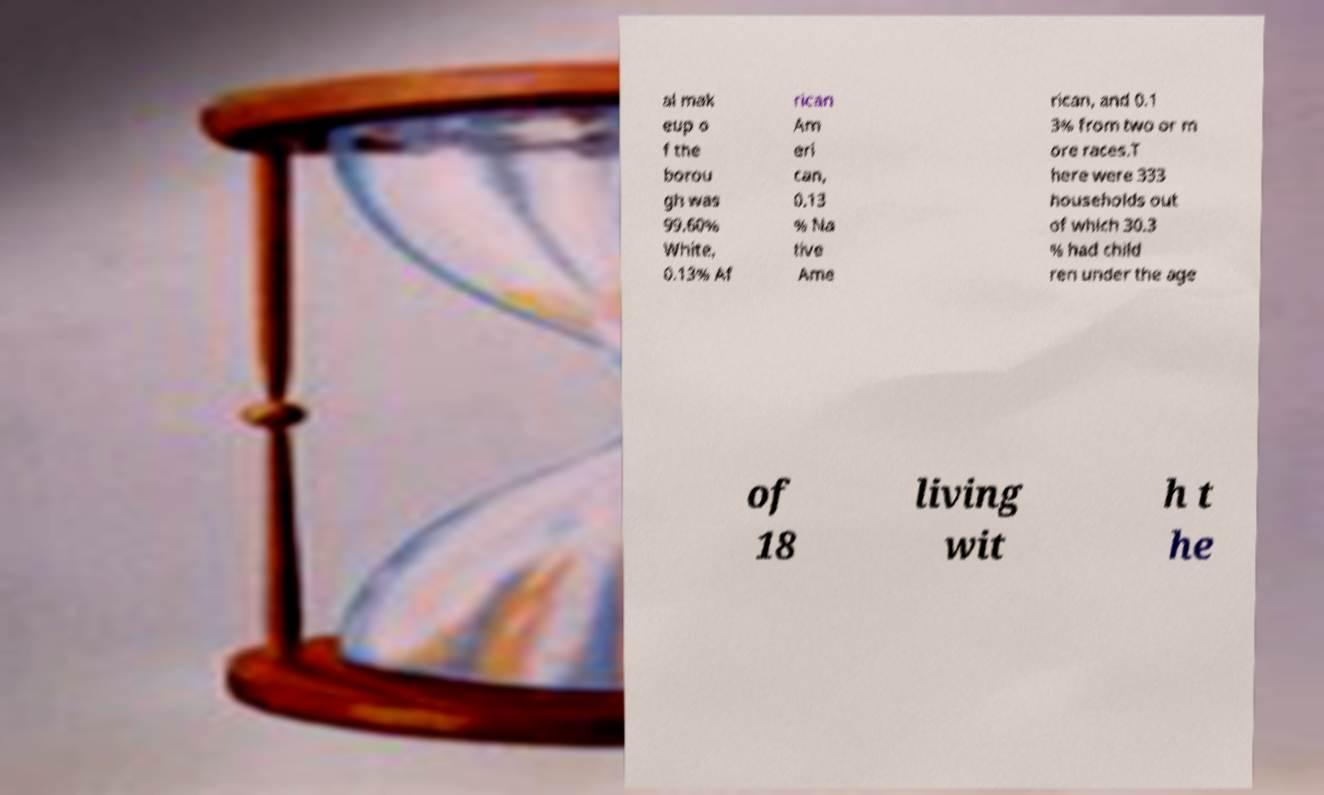I need the written content from this picture converted into text. Can you do that? al mak eup o f the borou gh was 99.60% White, 0.13% Af rican Am eri can, 0.13 % Na tive Ame rican, and 0.1 3% from two or m ore races.T here were 333 households out of which 30.3 % had child ren under the age of 18 living wit h t he 